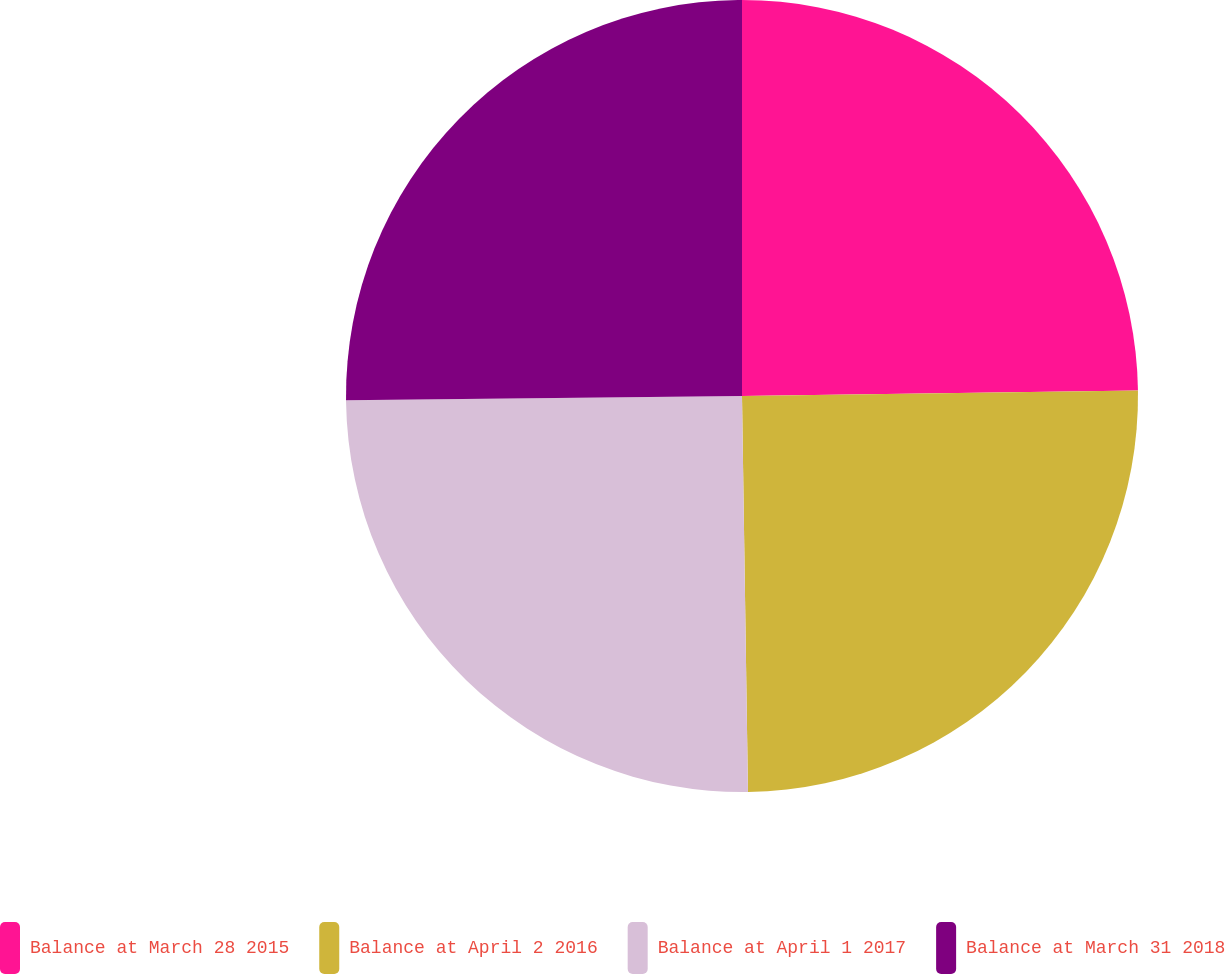Convert chart to OTSL. <chart><loc_0><loc_0><loc_500><loc_500><pie_chart><fcel>Balance at March 28 2015<fcel>Balance at April 2 2016<fcel>Balance at April 1 2017<fcel>Balance at March 31 2018<nl><fcel>24.78%<fcel>24.98%<fcel>25.07%<fcel>25.17%<nl></chart> 